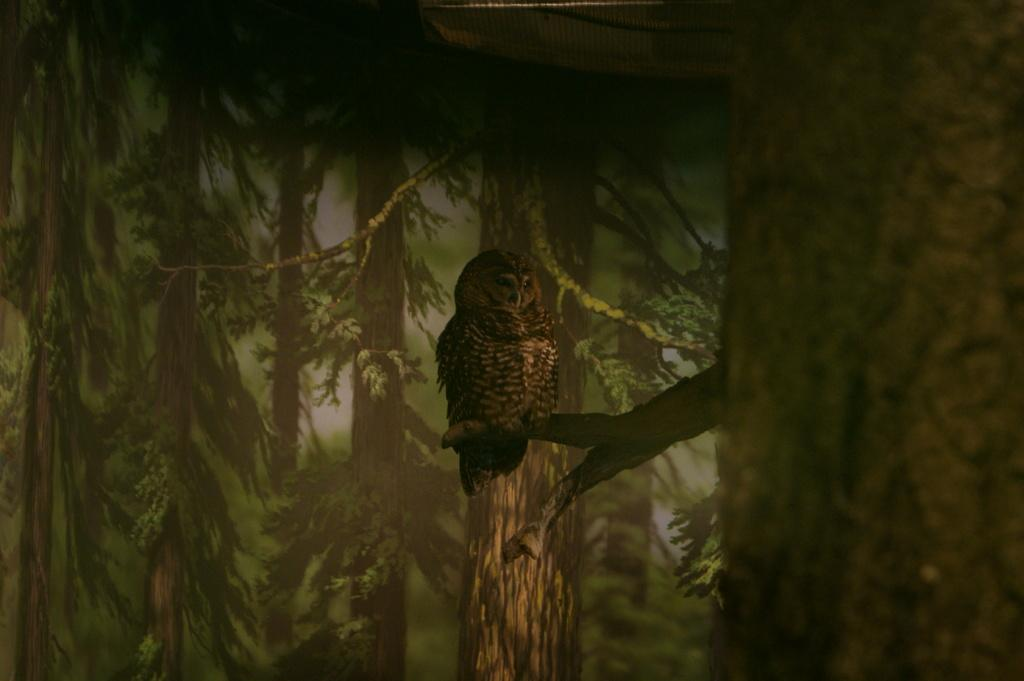What animal can be seen in the image? There is an owl in the image. Where is the owl located? The owl is standing on a branch of a tree. What can be seen in the background of the image? There are trees in the background of the image. What type of bubble is the owl holding in its talons? There is no bubble present in the image; the owl is standing on a branch of a tree. 